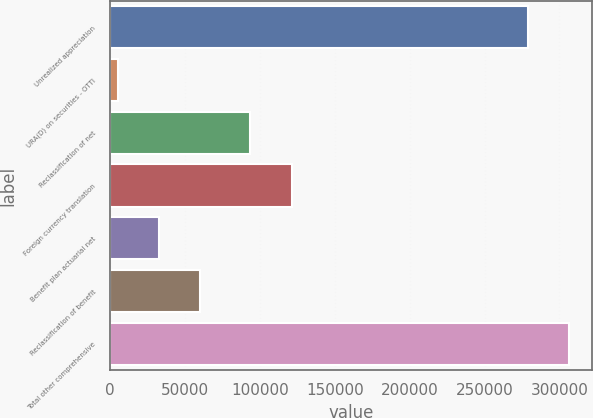<chart> <loc_0><loc_0><loc_500><loc_500><bar_chart><fcel>Unrealized appreciation<fcel>URA(D) on securities - OTTI<fcel>Reclassification of net<fcel>Foreign currency translation<fcel>Benefit plan actuarial net<fcel>Reclassification of benefit<fcel>Total other comprehensive<nl><fcel>279155<fcel>5028<fcel>93688<fcel>121192<fcel>32532.4<fcel>60036.8<fcel>306659<nl></chart> 